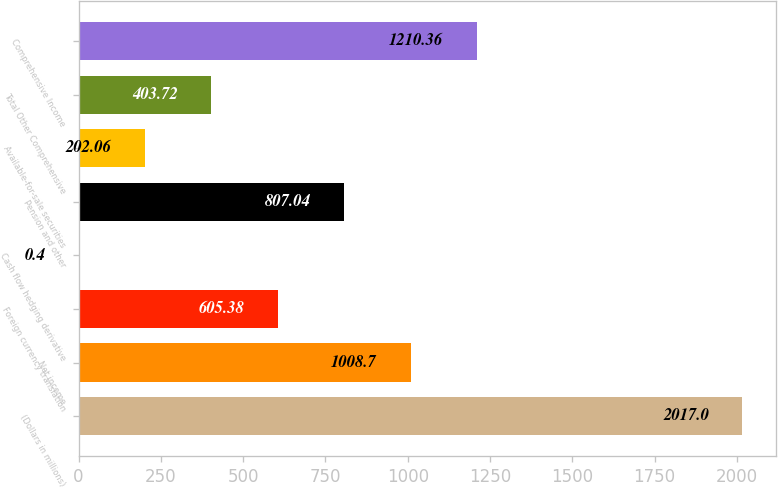<chart> <loc_0><loc_0><loc_500><loc_500><bar_chart><fcel>(Dollars in millions)<fcel>Net income<fcel>Foreign currency translation<fcel>Cash flow hedging derivative<fcel>Pension and other<fcel>Available-for-sale securities<fcel>Total Other Comprehensive<fcel>Comprehensive Income<nl><fcel>2017<fcel>1008.7<fcel>605.38<fcel>0.4<fcel>807.04<fcel>202.06<fcel>403.72<fcel>1210.36<nl></chart> 